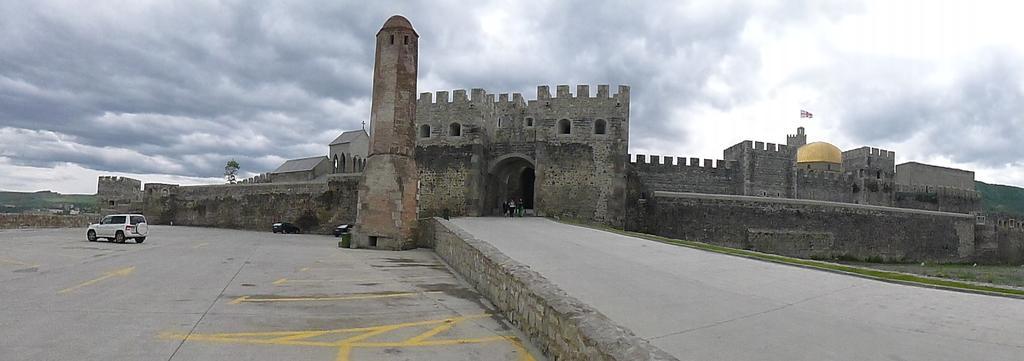In one or two sentences, can you explain what this image depicts? In the image we can see the fort and the flag. We can even see there are vehicles of different colors. There are even people wearing clothes. Here we can see the grass, footpath, hill and the cloudy sky. 